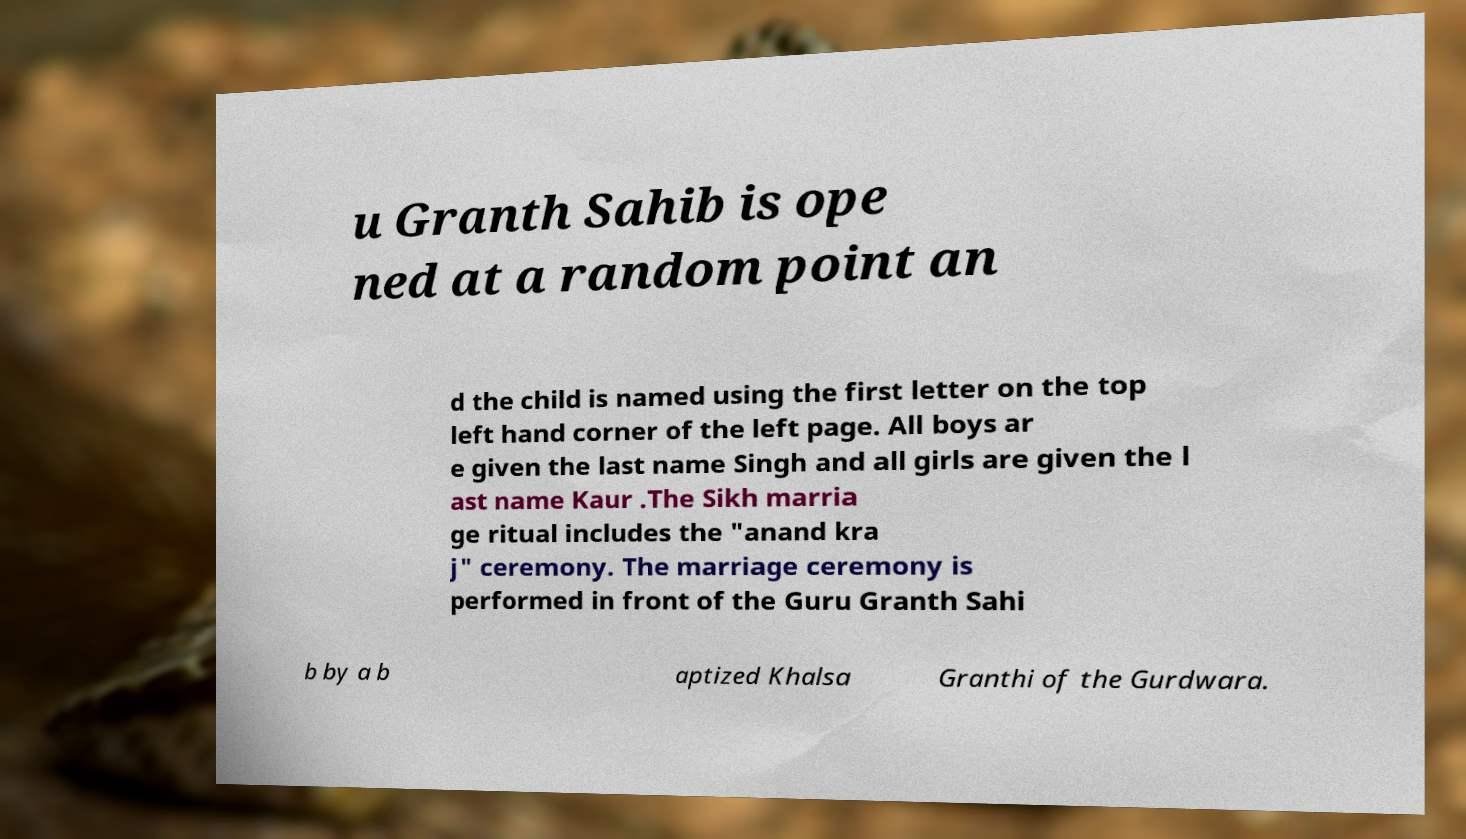Please read and relay the text visible in this image. What does it say? u Granth Sahib is ope ned at a random point an d the child is named using the first letter on the top left hand corner of the left page. All boys ar e given the last name Singh and all girls are given the l ast name Kaur .The Sikh marria ge ritual includes the "anand kra j" ceremony. The marriage ceremony is performed in front of the Guru Granth Sahi b by a b aptized Khalsa Granthi of the Gurdwara. 